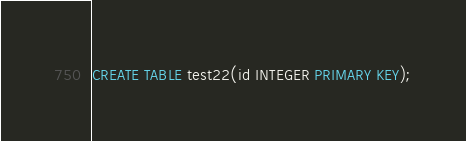Convert code to text. <code><loc_0><loc_0><loc_500><loc_500><_SQL_>CREATE TABLE test22(id INTEGER PRIMARY KEY);
</code> 